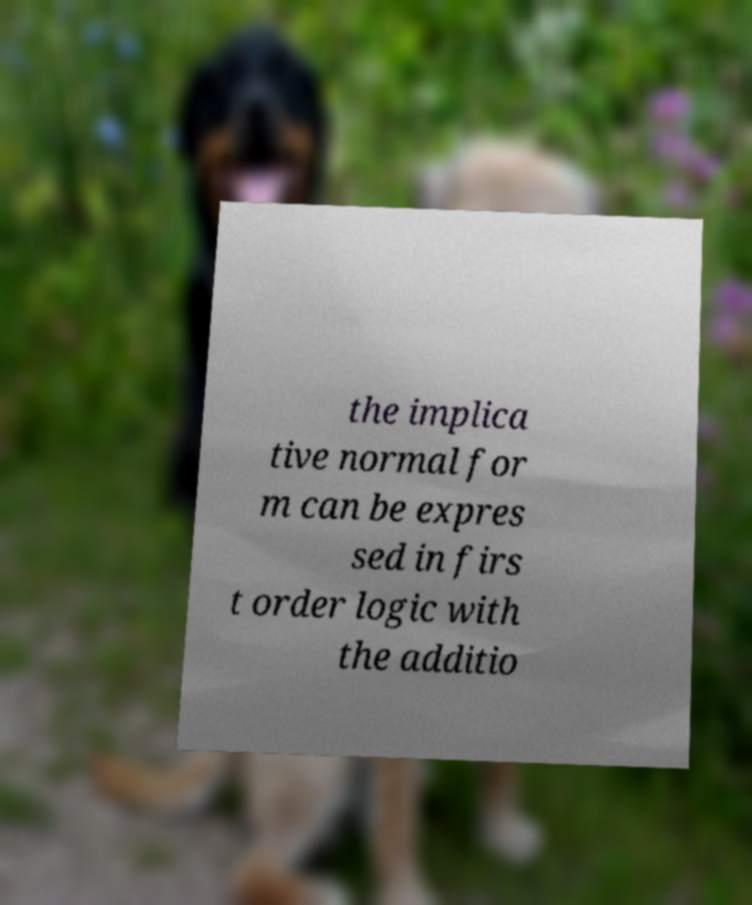Can you read and provide the text displayed in the image?This photo seems to have some interesting text. Can you extract and type it out for me? the implica tive normal for m can be expres sed in firs t order logic with the additio 